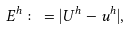<formula> <loc_0><loc_0><loc_500><loc_500>E ^ { h } \colon = | U ^ { h } - u ^ { h } | ,</formula> 